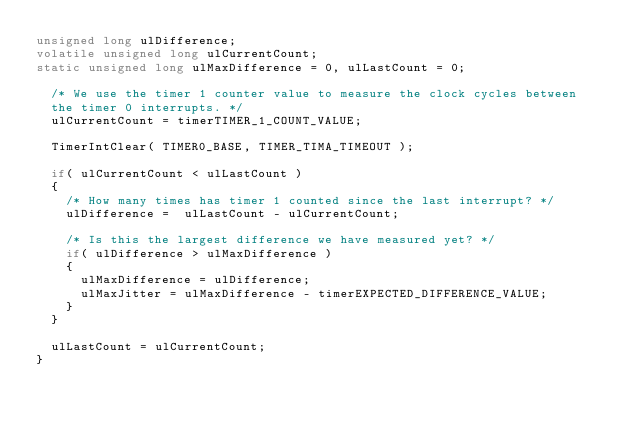<code> <loc_0><loc_0><loc_500><loc_500><_C_>unsigned long ulDifference;
volatile unsigned long ulCurrentCount;
static unsigned long ulMaxDifference = 0, ulLastCount = 0;

	/* We use the timer 1 counter value to measure the clock cycles between
	the timer 0 interrupts. */
	ulCurrentCount = timerTIMER_1_COUNT_VALUE;

	TimerIntClear( TIMER0_BASE, TIMER_TIMA_TIMEOUT );

	if( ulCurrentCount < ulLastCount )
	{	
		/* How many times has timer 1 counted since the last interrupt? */
		ulDifference = 	ulLastCount - ulCurrentCount;
	
		/* Is this the largest difference we have measured yet? */
		if( ulDifference > ulMaxDifference )
		{
			ulMaxDifference = ulDifference;
			ulMaxJitter = ulMaxDifference - timerEXPECTED_DIFFERENCE_VALUE;
		}
	}
	
	ulLastCount = ulCurrentCount;
}







</code> 